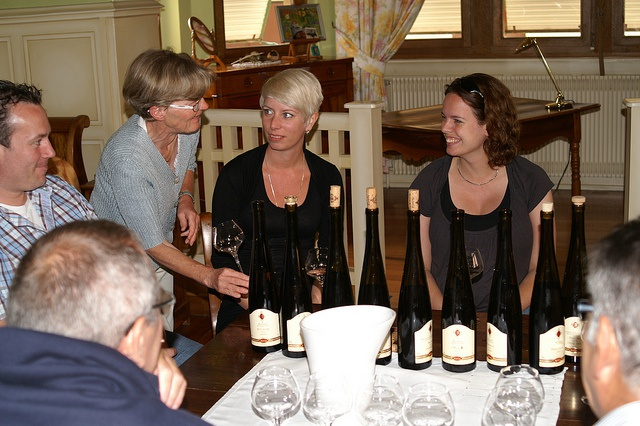Describe the objects in this image and their specific colors. I can see people in olive, gray, darkgray, and lightgray tones, dining table in olive, white, black, darkgray, and maroon tones, people in olive, black, brown, maroon, and salmon tones, people in olive, black, brown, and tan tones, and people in olive, darkgray, brown, gray, and maroon tones in this image. 